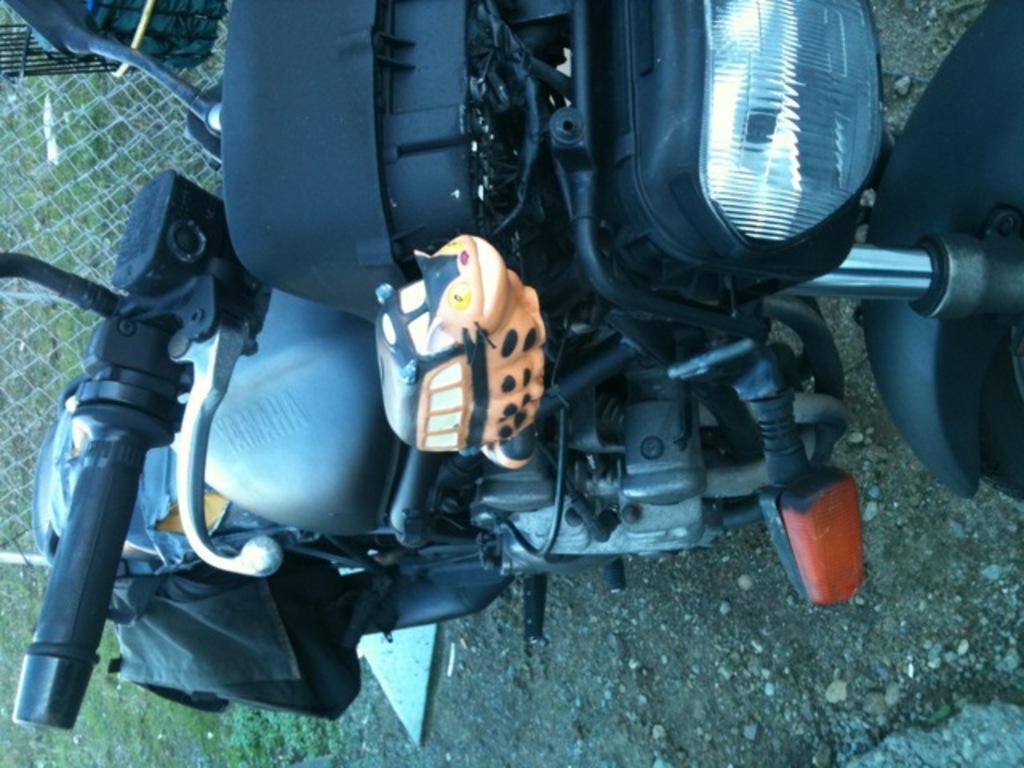Describe this image in one or two sentences. in the given picture i can see a vehicle which is parked and also i can see a toy which is attached to the vehicle and also i can see boundary grill. 